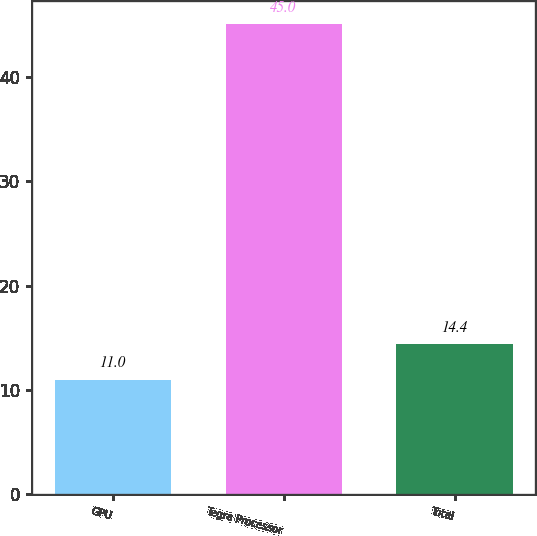Convert chart. <chart><loc_0><loc_0><loc_500><loc_500><bar_chart><fcel>GPU<fcel>Tegra Processor<fcel>Total<nl><fcel>11<fcel>45<fcel>14.4<nl></chart> 